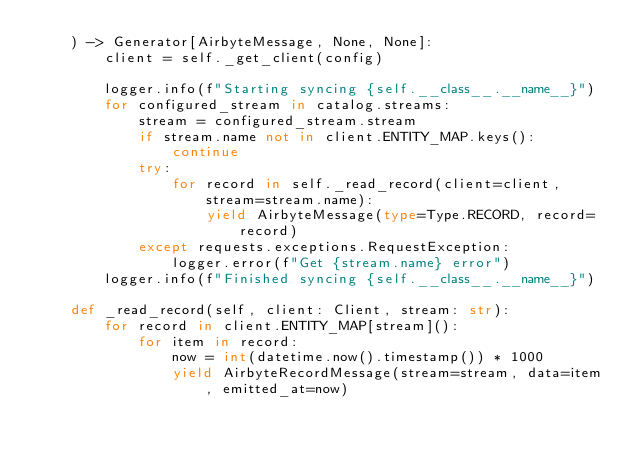<code> <loc_0><loc_0><loc_500><loc_500><_Python_>    ) -> Generator[AirbyteMessage, None, None]:
        client = self._get_client(config)

        logger.info(f"Starting syncing {self.__class__.__name__}")
        for configured_stream in catalog.streams:
            stream = configured_stream.stream
            if stream.name not in client.ENTITY_MAP.keys():
                continue
            try:
                for record in self._read_record(client=client, stream=stream.name):
                    yield AirbyteMessage(type=Type.RECORD, record=record)
            except requests.exceptions.RequestException:
                logger.error(f"Get {stream.name} error")
        logger.info(f"Finished syncing {self.__class__.__name__}")

    def _read_record(self, client: Client, stream: str):
        for record in client.ENTITY_MAP[stream]():
            for item in record:
                now = int(datetime.now().timestamp()) * 1000
                yield AirbyteRecordMessage(stream=stream, data=item, emitted_at=now)
</code> 